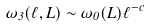Convert formula to latex. <formula><loc_0><loc_0><loc_500><loc_500>\omega _ { 3 } ( \ell , L ) \sim \omega _ { 0 } ( L ) \ell ^ { - c }</formula> 